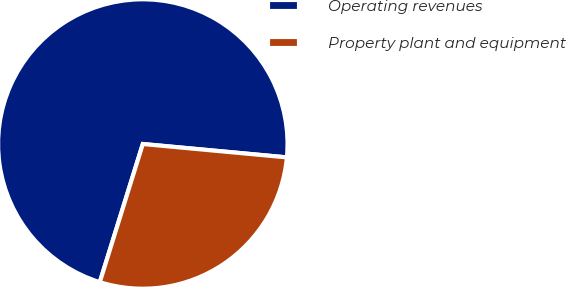Convert chart to OTSL. <chart><loc_0><loc_0><loc_500><loc_500><pie_chart><fcel>Operating revenues<fcel>Property plant and equipment<nl><fcel>71.67%<fcel>28.33%<nl></chart> 